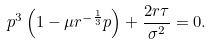<formula> <loc_0><loc_0><loc_500><loc_500>p ^ { 3 } \left ( 1 - \mu r ^ { - \frac { 1 } { 3 } } p \right ) + \frac { 2 r \tau } { \sigma ^ { 2 } } = 0 .</formula> 